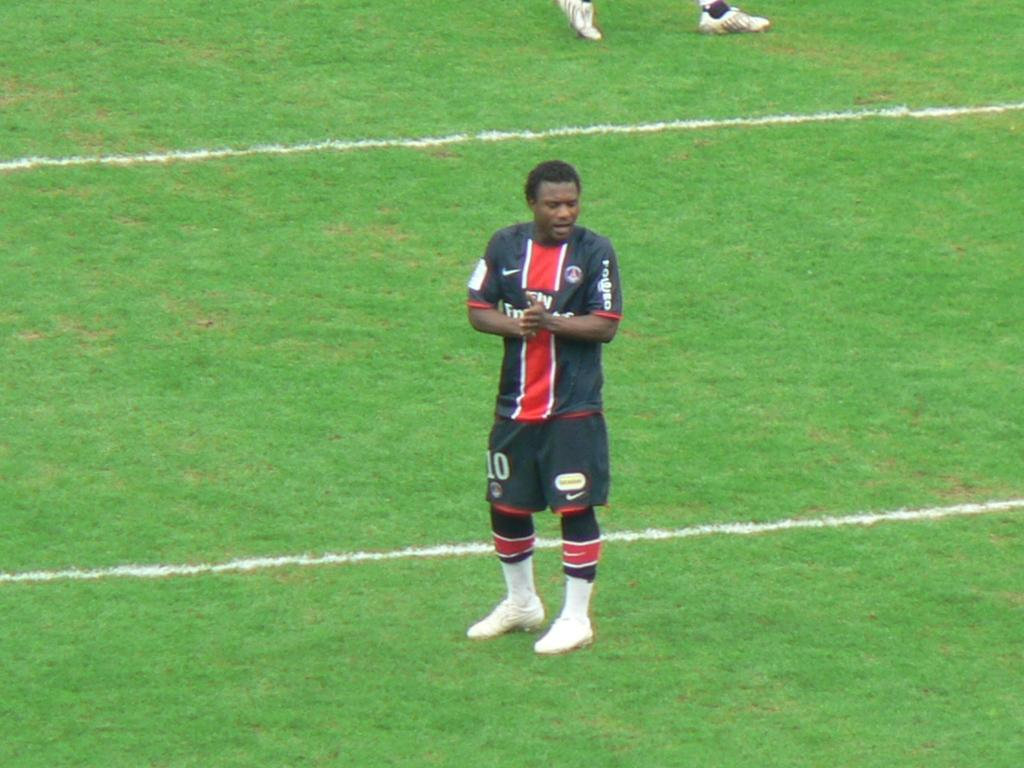Provide a one-sentence caption for the provided image. Soccer player number 10 stands on the field. 